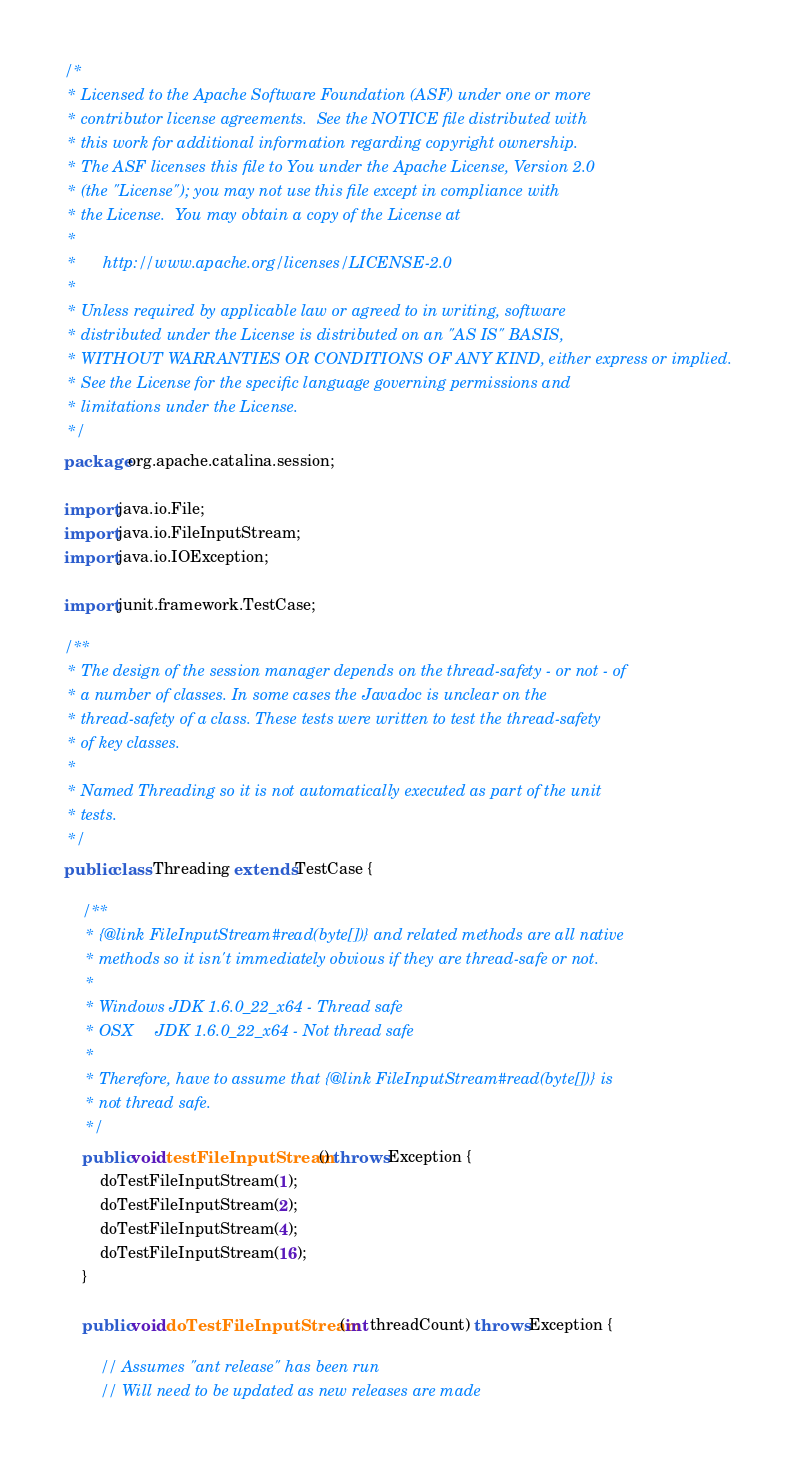<code> <loc_0><loc_0><loc_500><loc_500><_Java_>/*
 * Licensed to the Apache Software Foundation (ASF) under one or more
 * contributor license agreements.  See the NOTICE file distributed with
 * this work for additional information regarding copyright ownership.
 * The ASF licenses this file to You under the Apache License, Version 2.0
 * (the "License"); you may not use this file except in compliance with
 * the License.  You may obtain a copy of the License at
 * 
 *      http://www.apache.org/licenses/LICENSE-2.0
 * 
 * Unless required by applicable law or agreed to in writing, software
 * distributed under the License is distributed on an "AS IS" BASIS,
 * WITHOUT WARRANTIES OR CONDITIONS OF ANY KIND, either express or implied.
 * See the License for the specific language governing permissions and
 * limitations under the License.
 */
package org.apache.catalina.session;

import java.io.File;
import java.io.FileInputStream;
import java.io.IOException;

import junit.framework.TestCase;

/**
 * The design of the session manager depends on the thread-safety - or not - of
 * a number of classes. In some cases the Javadoc is unclear on the
 * thread-safety of a class. These tests were written to test the thread-safety
 * of key classes.
 * 
 * Named Threading so it is not automatically executed as part of the unit
 * tests.
 */
public class Threading extends TestCase {

    /**
     * {@link FileInputStream#read(byte[])} and related methods are all native
     * methods so it isn't immediately obvious if they are thread-safe or not.
     * 
     * Windows JDK 1.6.0_22_x64 - Thread safe
     * OSX     JDK 1.6.0_22_x64 - Not thread safe
     * 
     * Therefore, have to assume that {@link FileInputStream#read(byte[])} is
     * not thread safe.
     */
    public void testFileInputStream() throws Exception {
        doTestFileInputStream(1);
        doTestFileInputStream(2);
        doTestFileInputStream(4);
        doTestFileInputStream(16);
    }

    public void doTestFileInputStream(int threadCount) throws Exception {
        
        // Assumes "ant release" has been run
        // Will need to be updated as new releases are made</code> 